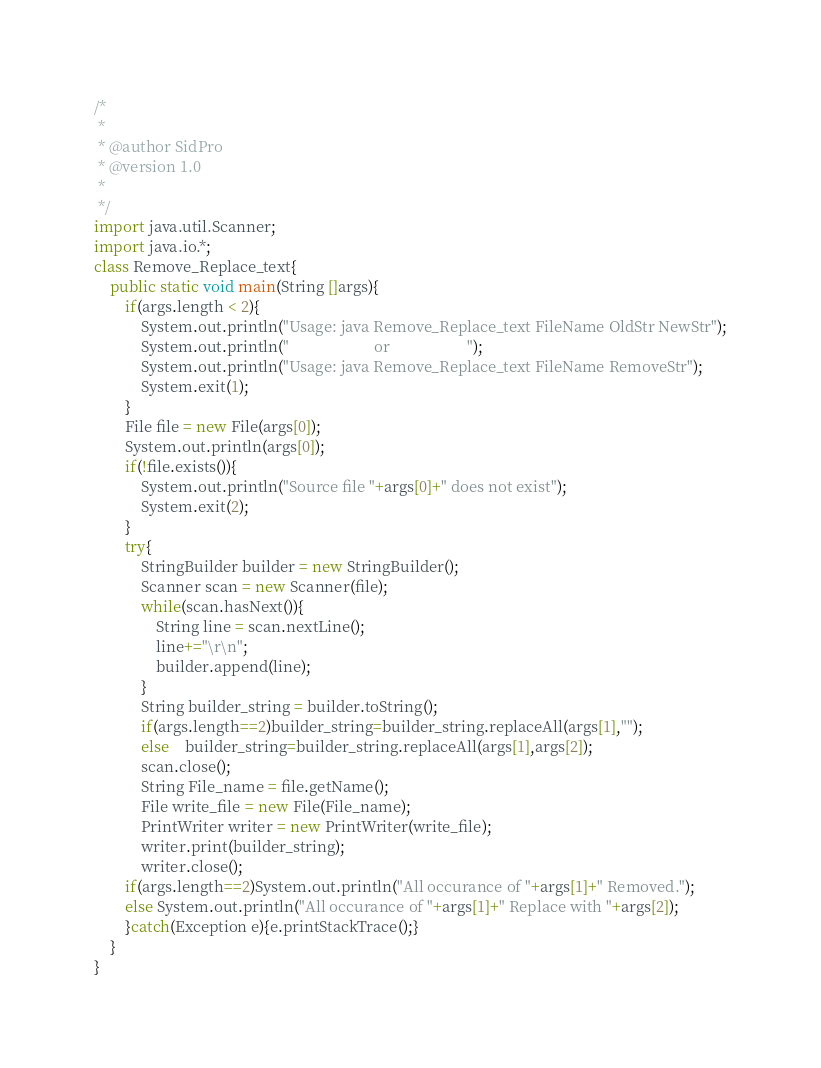Convert code to text. <code><loc_0><loc_0><loc_500><loc_500><_Java_>/*
 *
 * @author SidPro
 * @version 1.0
 *
 */
import java.util.Scanner;
import java.io.*;
class Remove_Replace_text{
	public static void main(String []args){
		if(args.length < 2){
			System.out.println("Usage: java Remove_Replace_text FileName OldStr NewStr");
			System.out.println("                      or                    ");
			System.out.println("Usage: java Remove_Replace_text FileName RemoveStr");
			System.exit(1);
		}
		File file = new File(args[0]);
		System.out.println(args[0]);
		if(!file.exists()){
			System.out.println("Source file "+args[0]+" does not exist");
			System.exit(2);
		}
		try{
			StringBuilder builder = new StringBuilder();
			Scanner scan = new Scanner(file);
			while(scan.hasNext()){
				String line = scan.nextLine();
				line+="\r\n";
				builder.append(line);
			}
			String builder_string = builder.toString();
			if(args.length==2)builder_string=builder_string.replaceAll(args[1],"");
			else	builder_string=builder_string.replaceAll(args[1],args[2]);
			scan.close();
			String File_name = file.getName();
			File write_file = new File(File_name);
			PrintWriter writer = new PrintWriter(write_file);
			writer.print(builder_string);
			writer.close(); 
		if(args.length==2)System.out.println("All occurance of "+args[1]+" Removed.");
		else System.out.println("All occurance of "+args[1]+" Replace with "+args[2]);
		}catch(Exception e){e.printStackTrace();}
	}
}</code> 